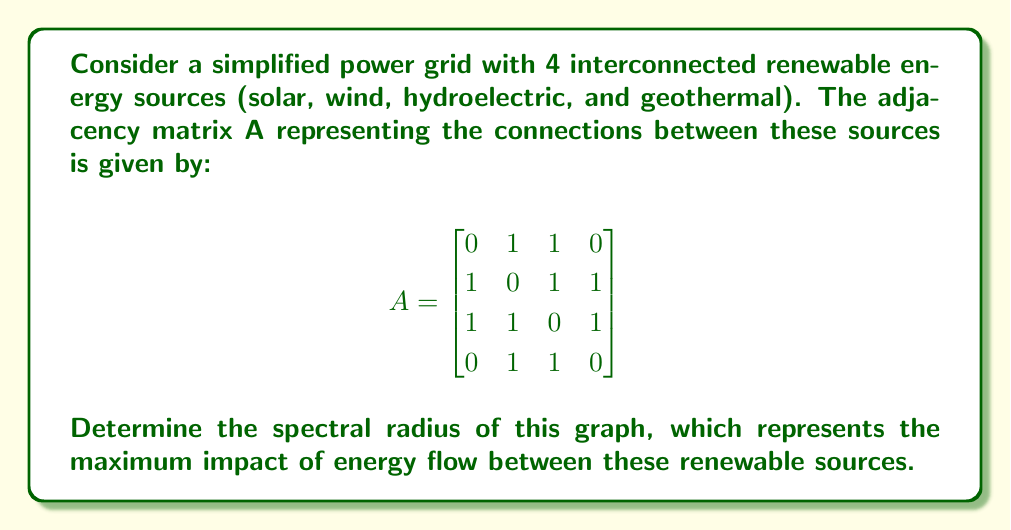Solve this math problem. To find the spectral radius of the graph, we need to follow these steps:

1) The spectral radius is the largest absolute eigenvalue of the adjacency matrix A.

2) To find the eigenvalues, we need to solve the characteristic equation:
   $\det(A - \lambda I) = 0$

3) Expanding the determinant:
   $$\begin{vmatrix}
   -\lambda & 1 & 1 & 0 \\
   1 & -\lambda & 1 & 1 \\
   1 & 1 & -\lambda & 1 \\
   0 & 1 & 1 & -\lambda
   \end{vmatrix} = 0$$

4) This expands to the characteristic polynomial:
   $\lambda^4 - 5\lambda^2 + 4 = 0$

5) This is a quadratic equation in $\lambda^2$. Let $u = \lambda^2$:
   $u^2 - 5u + 4 = 0$

6) Solving this quadratic equation:
   $u = \frac{5 \pm \sqrt{25 - 16}}{2} = \frac{5 \pm 3}{2}$

7) So, $u = 4$ or $u = 1$

8) Since $u = \lambda^2$, the eigenvalues are:
   $\lambda = \pm 2$ or $\lambda = \pm 1$

9) The spectral radius is the largest absolute value among these eigenvalues, which is 2.
Answer: 2 